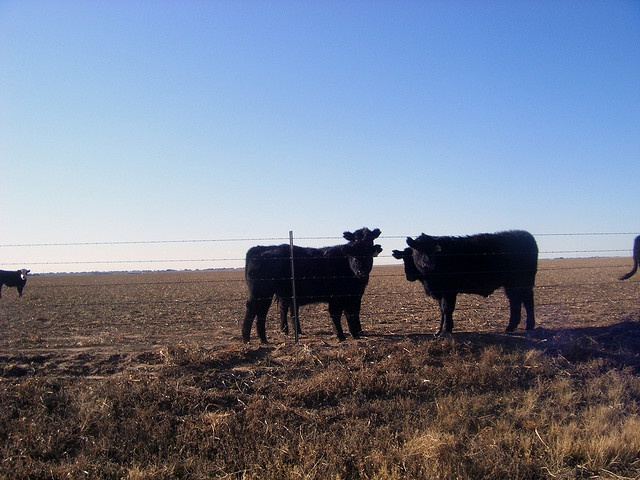Describe the objects in this image and their specific colors. I can see cow in lightblue, black, and gray tones, cow in lightblue, black, navy, and gray tones, cow in lightblue, black, gray, and navy tones, and cow in lightblue, black, gray, lightgray, and navy tones in this image. 